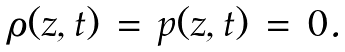<formula> <loc_0><loc_0><loc_500><loc_500>\begin{array} { l l } \rho ( z , t ) \, = \, p ( z , t ) \, = \, 0 . \end{array}</formula> 